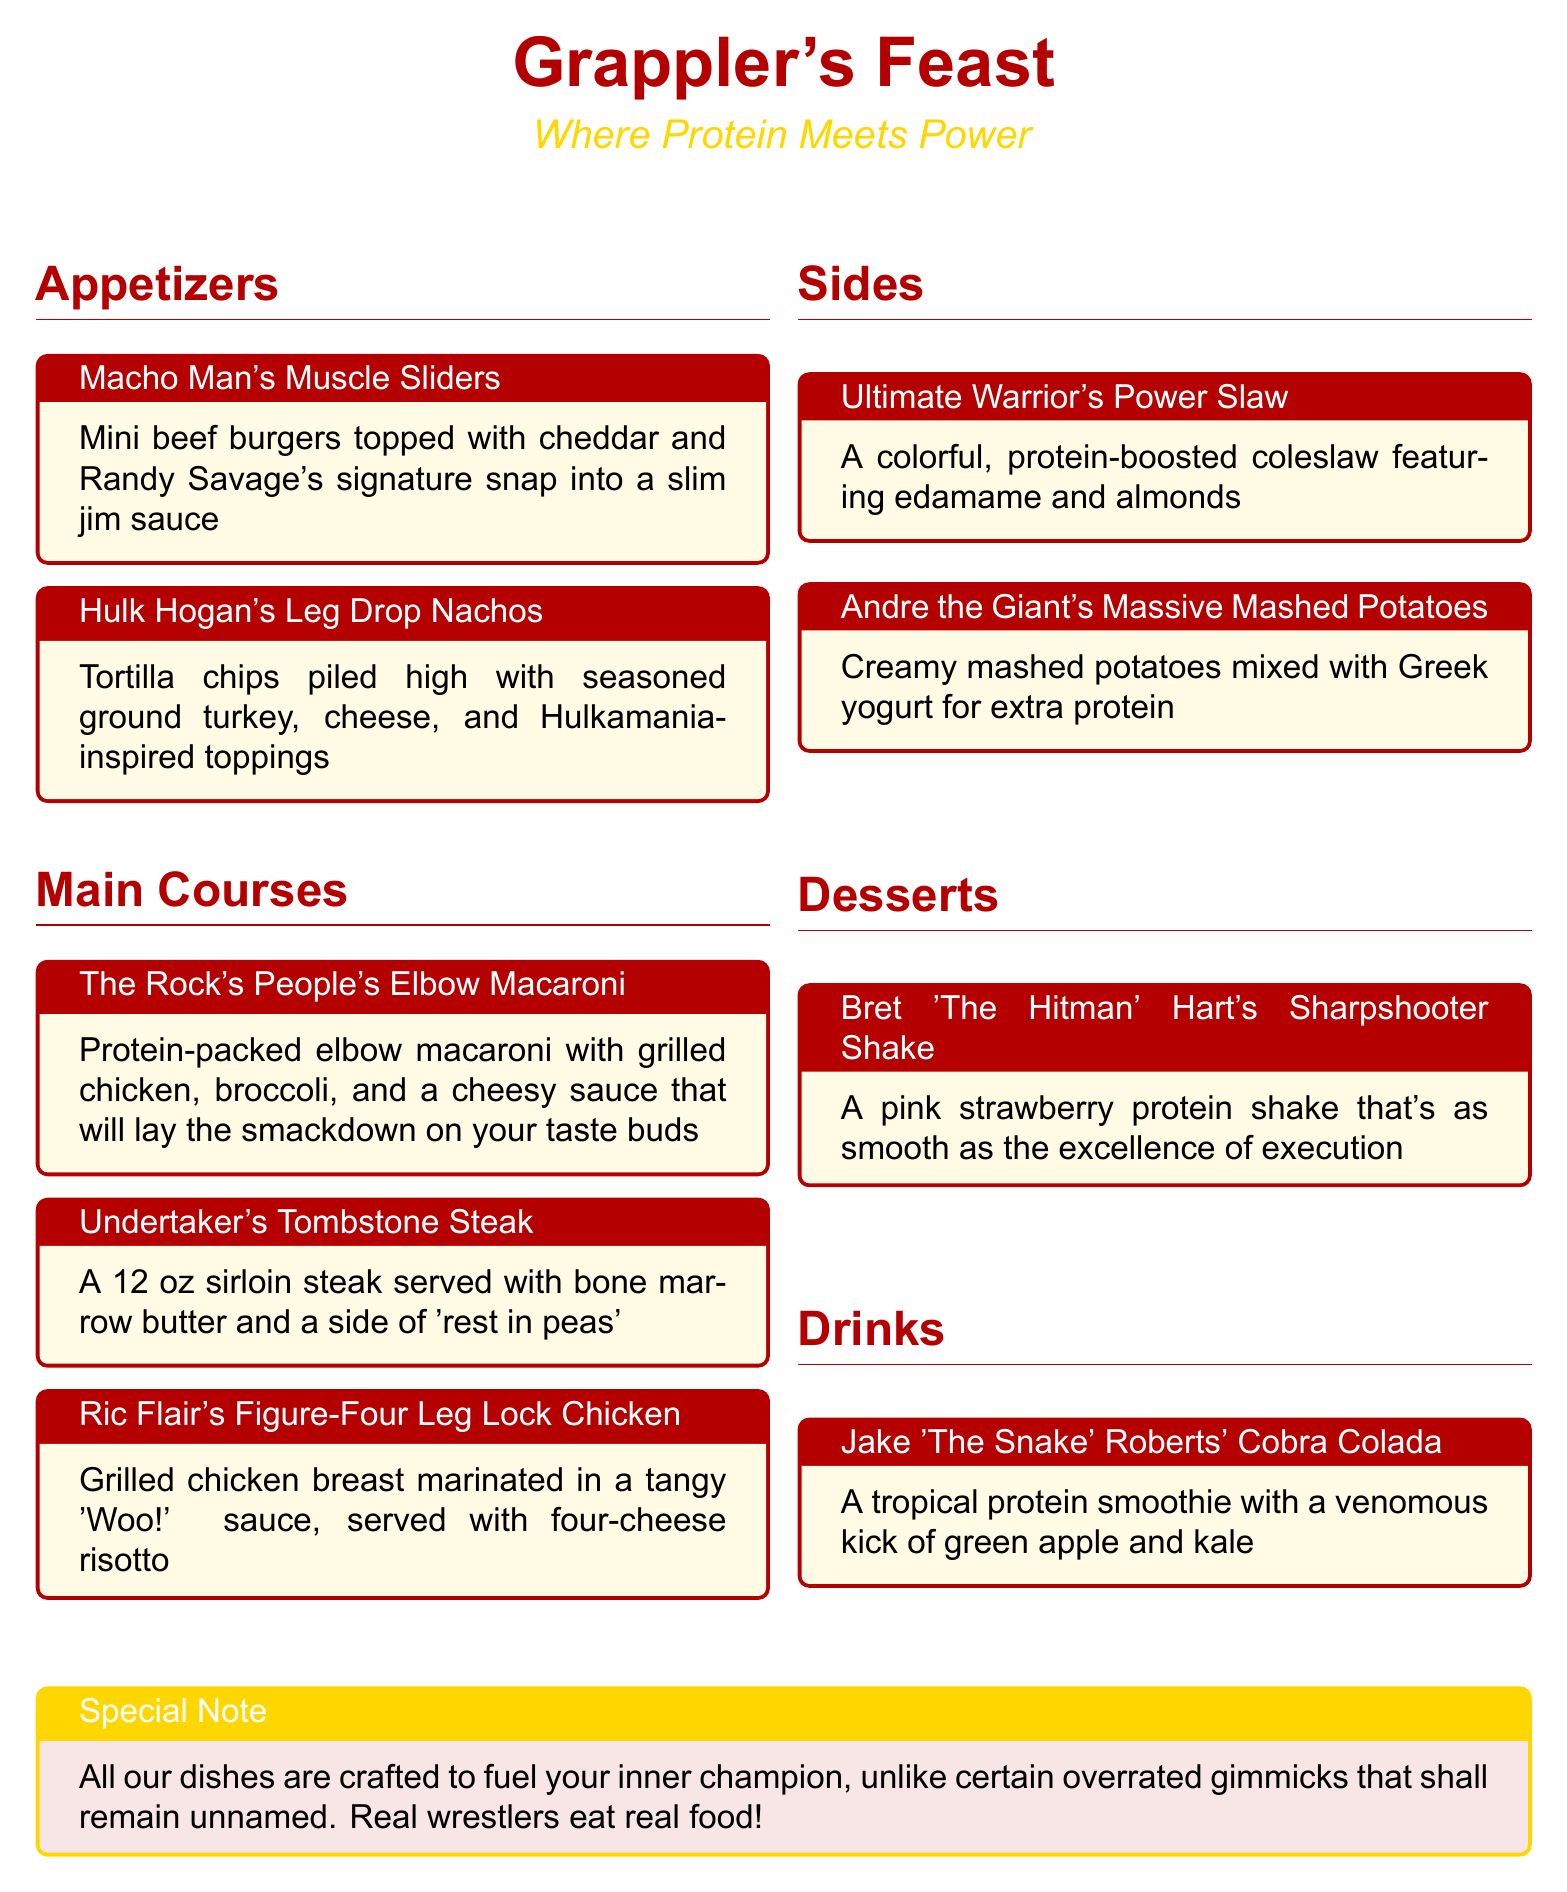What is the title of the menu? The title of the menu is prominently displayed at the top of the document.
Answer: Grappler's Feast What color is used for the main title? The menu specifies the color of the main title, which is also indicated in the styling choices.
Answer: Wrestlered What dish is named after Hulk Hogan? This dish is specifically highlighted in the appetizers section.
Answer: Hulk Hogan's Leg Drop Nachos How many ounces is the Undertaker's Tombstone Steak? The size of the steak is stated in the main courses section.
Answer: 12 oz What type of shake is Bret 'The Hitman' Hart's dessert? The menu describes the type of dessert shake offered.
Answer: Strawberry protein shake What is the main ingredient in Jake 'The Snake' Roberts' drink? The drink’s composition is detailed in the drinks section of the menu.
Answer: Protein smoothie Which wrestler's dish includes four-cheese risotto? This dish is named after a famous wrestler and includes specific ingredients.
Answer: Ric Flair's Figure-Four Leg Lock Chicken What additional ingredient is in Andre the Giant's Massive Mashed Potatoes? The document mentions the additional ingredient for this side dish in the description.
Answer: Greek yogurt What special note is included in the menu? The menu concludes with a note addressing certain themes related to the food.
Answer: All our dishes are crafted to fuel your inner champion What type of coleslaw is mentioned in the sides section? The details about this dish highlight its unique ingredients and characteristics.
Answer: Protein-boosted coleslaw 